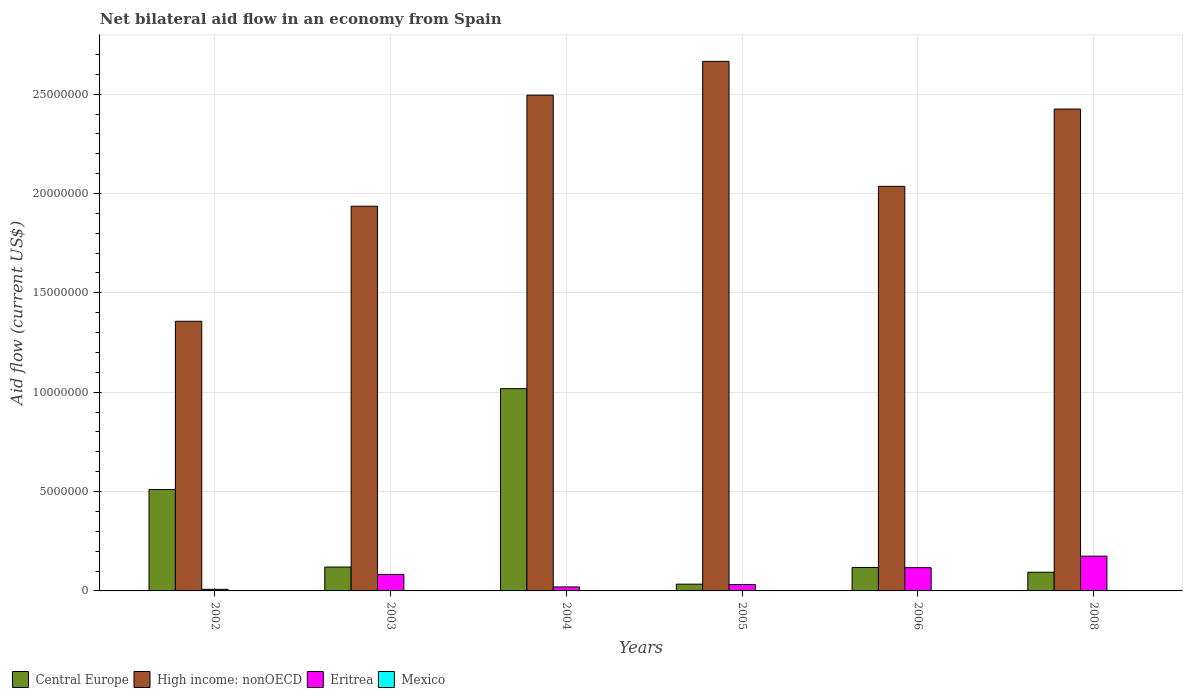How many groups of bars are there?
Your answer should be compact. 6. Are the number of bars per tick equal to the number of legend labels?
Your answer should be compact. No. What is the label of the 2nd group of bars from the left?
Your response must be concise. 2003. In how many cases, is the number of bars for a given year not equal to the number of legend labels?
Keep it short and to the point. 6. What is the net bilateral aid flow in Mexico in 2002?
Your answer should be very brief. 0. Across all years, what is the maximum net bilateral aid flow in Central Europe?
Keep it short and to the point. 1.02e+07. In which year was the net bilateral aid flow in Central Europe maximum?
Ensure brevity in your answer.  2004. What is the total net bilateral aid flow in Eritrea in the graph?
Your response must be concise. 4.35e+06. What is the difference between the net bilateral aid flow in Central Europe in 2002 and that in 2003?
Your answer should be very brief. 3.90e+06. What is the difference between the net bilateral aid flow in High income: nonOECD in 2005 and the net bilateral aid flow in Eritrea in 2004?
Your answer should be very brief. 2.64e+07. What is the average net bilateral aid flow in High income: nonOECD per year?
Keep it short and to the point. 2.15e+07. In the year 2004, what is the difference between the net bilateral aid flow in Central Europe and net bilateral aid flow in Eritrea?
Provide a succinct answer. 9.98e+06. In how many years, is the net bilateral aid flow in High income: nonOECD greater than 2000000 US$?
Give a very brief answer. 6. What is the ratio of the net bilateral aid flow in Central Europe in 2003 to that in 2005?
Ensure brevity in your answer.  3.53. What is the difference between the highest and the second highest net bilateral aid flow in High income: nonOECD?
Offer a very short reply. 1.70e+06. What is the difference between the highest and the lowest net bilateral aid flow in Central Europe?
Your answer should be very brief. 9.84e+06. Is the sum of the net bilateral aid flow in High income: nonOECD in 2002 and 2003 greater than the maximum net bilateral aid flow in Mexico across all years?
Your answer should be very brief. Yes. Is it the case that in every year, the sum of the net bilateral aid flow in Mexico and net bilateral aid flow in Central Europe is greater than the net bilateral aid flow in High income: nonOECD?
Keep it short and to the point. No. How many bars are there?
Offer a terse response. 18. How many years are there in the graph?
Your response must be concise. 6. What is the difference between two consecutive major ticks on the Y-axis?
Make the answer very short. 5.00e+06. Are the values on the major ticks of Y-axis written in scientific E-notation?
Your answer should be compact. No. Does the graph contain any zero values?
Make the answer very short. Yes. Does the graph contain grids?
Provide a short and direct response. Yes. Where does the legend appear in the graph?
Your answer should be compact. Bottom left. How many legend labels are there?
Your response must be concise. 4. What is the title of the graph?
Your answer should be very brief. Net bilateral aid flow in an economy from Spain. Does "Congo (Republic)" appear as one of the legend labels in the graph?
Keep it short and to the point. No. What is the Aid flow (current US$) in Central Europe in 2002?
Make the answer very short. 5.10e+06. What is the Aid flow (current US$) in High income: nonOECD in 2002?
Provide a succinct answer. 1.36e+07. What is the Aid flow (current US$) in Mexico in 2002?
Offer a very short reply. 0. What is the Aid flow (current US$) of Central Europe in 2003?
Provide a succinct answer. 1.20e+06. What is the Aid flow (current US$) in High income: nonOECD in 2003?
Offer a terse response. 1.94e+07. What is the Aid flow (current US$) in Eritrea in 2003?
Give a very brief answer. 8.30e+05. What is the Aid flow (current US$) in Mexico in 2003?
Provide a succinct answer. 0. What is the Aid flow (current US$) in Central Europe in 2004?
Ensure brevity in your answer.  1.02e+07. What is the Aid flow (current US$) of High income: nonOECD in 2004?
Your answer should be compact. 2.50e+07. What is the Aid flow (current US$) in Eritrea in 2004?
Offer a terse response. 2.00e+05. What is the Aid flow (current US$) in Mexico in 2004?
Provide a short and direct response. 0. What is the Aid flow (current US$) of High income: nonOECD in 2005?
Your answer should be compact. 2.66e+07. What is the Aid flow (current US$) of Mexico in 2005?
Your answer should be compact. 0. What is the Aid flow (current US$) of Central Europe in 2006?
Keep it short and to the point. 1.18e+06. What is the Aid flow (current US$) in High income: nonOECD in 2006?
Offer a very short reply. 2.04e+07. What is the Aid flow (current US$) in Eritrea in 2006?
Offer a terse response. 1.17e+06. What is the Aid flow (current US$) of Mexico in 2006?
Offer a terse response. 0. What is the Aid flow (current US$) in Central Europe in 2008?
Your response must be concise. 9.40e+05. What is the Aid flow (current US$) of High income: nonOECD in 2008?
Give a very brief answer. 2.42e+07. What is the Aid flow (current US$) in Eritrea in 2008?
Provide a short and direct response. 1.75e+06. What is the Aid flow (current US$) in Mexico in 2008?
Your answer should be very brief. 0. Across all years, what is the maximum Aid flow (current US$) in Central Europe?
Offer a very short reply. 1.02e+07. Across all years, what is the maximum Aid flow (current US$) in High income: nonOECD?
Offer a very short reply. 2.66e+07. Across all years, what is the maximum Aid flow (current US$) in Eritrea?
Provide a succinct answer. 1.75e+06. Across all years, what is the minimum Aid flow (current US$) of High income: nonOECD?
Provide a succinct answer. 1.36e+07. What is the total Aid flow (current US$) in Central Europe in the graph?
Offer a very short reply. 1.89e+07. What is the total Aid flow (current US$) in High income: nonOECD in the graph?
Offer a very short reply. 1.29e+08. What is the total Aid flow (current US$) in Eritrea in the graph?
Your response must be concise. 4.35e+06. What is the total Aid flow (current US$) of Mexico in the graph?
Your answer should be compact. 0. What is the difference between the Aid flow (current US$) in Central Europe in 2002 and that in 2003?
Offer a very short reply. 3.90e+06. What is the difference between the Aid flow (current US$) of High income: nonOECD in 2002 and that in 2003?
Provide a succinct answer. -5.79e+06. What is the difference between the Aid flow (current US$) of Eritrea in 2002 and that in 2003?
Your answer should be very brief. -7.50e+05. What is the difference between the Aid flow (current US$) in Central Europe in 2002 and that in 2004?
Provide a succinct answer. -5.08e+06. What is the difference between the Aid flow (current US$) in High income: nonOECD in 2002 and that in 2004?
Ensure brevity in your answer.  -1.14e+07. What is the difference between the Aid flow (current US$) of Eritrea in 2002 and that in 2004?
Your response must be concise. -1.20e+05. What is the difference between the Aid flow (current US$) of Central Europe in 2002 and that in 2005?
Offer a very short reply. 4.76e+06. What is the difference between the Aid flow (current US$) in High income: nonOECD in 2002 and that in 2005?
Ensure brevity in your answer.  -1.31e+07. What is the difference between the Aid flow (current US$) of Central Europe in 2002 and that in 2006?
Your answer should be very brief. 3.92e+06. What is the difference between the Aid flow (current US$) in High income: nonOECD in 2002 and that in 2006?
Keep it short and to the point. -6.79e+06. What is the difference between the Aid flow (current US$) of Eritrea in 2002 and that in 2006?
Give a very brief answer. -1.09e+06. What is the difference between the Aid flow (current US$) in Central Europe in 2002 and that in 2008?
Provide a succinct answer. 4.16e+06. What is the difference between the Aid flow (current US$) in High income: nonOECD in 2002 and that in 2008?
Your response must be concise. -1.07e+07. What is the difference between the Aid flow (current US$) in Eritrea in 2002 and that in 2008?
Your response must be concise. -1.67e+06. What is the difference between the Aid flow (current US$) of Central Europe in 2003 and that in 2004?
Make the answer very short. -8.98e+06. What is the difference between the Aid flow (current US$) of High income: nonOECD in 2003 and that in 2004?
Provide a short and direct response. -5.59e+06. What is the difference between the Aid flow (current US$) of Eritrea in 2003 and that in 2004?
Your response must be concise. 6.30e+05. What is the difference between the Aid flow (current US$) in Central Europe in 2003 and that in 2005?
Keep it short and to the point. 8.60e+05. What is the difference between the Aid flow (current US$) in High income: nonOECD in 2003 and that in 2005?
Keep it short and to the point. -7.29e+06. What is the difference between the Aid flow (current US$) of Eritrea in 2003 and that in 2005?
Your answer should be very brief. 5.10e+05. What is the difference between the Aid flow (current US$) of High income: nonOECD in 2003 and that in 2006?
Offer a very short reply. -1.00e+06. What is the difference between the Aid flow (current US$) in High income: nonOECD in 2003 and that in 2008?
Offer a terse response. -4.89e+06. What is the difference between the Aid flow (current US$) of Eritrea in 2003 and that in 2008?
Your answer should be compact. -9.20e+05. What is the difference between the Aid flow (current US$) of Central Europe in 2004 and that in 2005?
Your response must be concise. 9.84e+06. What is the difference between the Aid flow (current US$) of High income: nonOECD in 2004 and that in 2005?
Keep it short and to the point. -1.70e+06. What is the difference between the Aid flow (current US$) in Eritrea in 2004 and that in 2005?
Your answer should be compact. -1.20e+05. What is the difference between the Aid flow (current US$) in Central Europe in 2004 and that in 2006?
Your response must be concise. 9.00e+06. What is the difference between the Aid flow (current US$) in High income: nonOECD in 2004 and that in 2006?
Provide a short and direct response. 4.59e+06. What is the difference between the Aid flow (current US$) in Eritrea in 2004 and that in 2006?
Provide a succinct answer. -9.70e+05. What is the difference between the Aid flow (current US$) in Central Europe in 2004 and that in 2008?
Offer a very short reply. 9.24e+06. What is the difference between the Aid flow (current US$) of Eritrea in 2004 and that in 2008?
Your response must be concise. -1.55e+06. What is the difference between the Aid flow (current US$) in Central Europe in 2005 and that in 2006?
Keep it short and to the point. -8.40e+05. What is the difference between the Aid flow (current US$) in High income: nonOECD in 2005 and that in 2006?
Provide a short and direct response. 6.29e+06. What is the difference between the Aid flow (current US$) in Eritrea in 2005 and that in 2006?
Give a very brief answer. -8.50e+05. What is the difference between the Aid flow (current US$) of Central Europe in 2005 and that in 2008?
Your response must be concise. -6.00e+05. What is the difference between the Aid flow (current US$) in High income: nonOECD in 2005 and that in 2008?
Provide a succinct answer. 2.40e+06. What is the difference between the Aid flow (current US$) of Eritrea in 2005 and that in 2008?
Your answer should be very brief. -1.43e+06. What is the difference between the Aid flow (current US$) in Central Europe in 2006 and that in 2008?
Your answer should be very brief. 2.40e+05. What is the difference between the Aid flow (current US$) in High income: nonOECD in 2006 and that in 2008?
Make the answer very short. -3.89e+06. What is the difference between the Aid flow (current US$) in Eritrea in 2006 and that in 2008?
Provide a succinct answer. -5.80e+05. What is the difference between the Aid flow (current US$) in Central Europe in 2002 and the Aid flow (current US$) in High income: nonOECD in 2003?
Make the answer very short. -1.43e+07. What is the difference between the Aid flow (current US$) in Central Europe in 2002 and the Aid flow (current US$) in Eritrea in 2003?
Give a very brief answer. 4.27e+06. What is the difference between the Aid flow (current US$) of High income: nonOECD in 2002 and the Aid flow (current US$) of Eritrea in 2003?
Ensure brevity in your answer.  1.27e+07. What is the difference between the Aid flow (current US$) in Central Europe in 2002 and the Aid flow (current US$) in High income: nonOECD in 2004?
Your answer should be very brief. -1.98e+07. What is the difference between the Aid flow (current US$) in Central Europe in 2002 and the Aid flow (current US$) in Eritrea in 2004?
Offer a terse response. 4.90e+06. What is the difference between the Aid flow (current US$) of High income: nonOECD in 2002 and the Aid flow (current US$) of Eritrea in 2004?
Make the answer very short. 1.34e+07. What is the difference between the Aid flow (current US$) in Central Europe in 2002 and the Aid flow (current US$) in High income: nonOECD in 2005?
Ensure brevity in your answer.  -2.16e+07. What is the difference between the Aid flow (current US$) of Central Europe in 2002 and the Aid flow (current US$) of Eritrea in 2005?
Provide a succinct answer. 4.78e+06. What is the difference between the Aid flow (current US$) in High income: nonOECD in 2002 and the Aid flow (current US$) in Eritrea in 2005?
Your answer should be compact. 1.32e+07. What is the difference between the Aid flow (current US$) of Central Europe in 2002 and the Aid flow (current US$) of High income: nonOECD in 2006?
Keep it short and to the point. -1.53e+07. What is the difference between the Aid flow (current US$) in Central Europe in 2002 and the Aid flow (current US$) in Eritrea in 2006?
Your answer should be very brief. 3.93e+06. What is the difference between the Aid flow (current US$) in High income: nonOECD in 2002 and the Aid flow (current US$) in Eritrea in 2006?
Your response must be concise. 1.24e+07. What is the difference between the Aid flow (current US$) in Central Europe in 2002 and the Aid flow (current US$) in High income: nonOECD in 2008?
Offer a terse response. -1.92e+07. What is the difference between the Aid flow (current US$) of Central Europe in 2002 and the Aid flow (current US$) of Eritrea in 2008?
Ensure brevity in your answer.  3.35e+06. What is the difference between the Aid flow (current US$) of High income: nonOECD in 2002 and the Aid flow (current US$) of Eritrea in 2008?
Your answer should be very brief. 1.18e+07. What is the difference between the Aid flow (current US$) in Central Europe in 2003 and the Aid flow (current US$) in High income: nonOECD in 2004?
Offer a very short reply. -2.38e+07. What is the difference between the Aid flow (current US$) of Central Europe in 2003 and the Aid flow (current US$) of Eritrea in 2004?
Keep it short and to the point. 1.00e+06. What is the difference between the Aid flow (current US$) of High income: nonOECD in 2003 and the Aid flow (current US$) of Eritrea in 2004?
Keep it short and to the point. 1.92e+07. What is the difference between the Aid flow (current US$) of Central Europe in 2003 and the Aid flow (current US$) of High income: nonOECD in 2005?
Offer a very short reply. -2.54e+07. What is the difference between the Aid flow (current US$) in Central Europe in 2003 and the Aid flow (current US$) in Eritrea in 2005?
Your answer should be compact. 8.80e+05. What is the difference between the Aid flow (current US$) of High income: nonOECD in 2003 and the Aid flow (current US$) of Eritrea in 2005?
Make the answer very short. 1.90e+07. What is the difference between the Aid flow (current US$) of Central Europe in 2003 and the Aid flow (current US$) of High income: nonOECD in 2006?
Provide a short and direct response. -1.92e+07. What is the difference between the Aid flow (current US$) of High income: nonOECD in 2003 and the Aid flow (current US$) of Eritrea in 2006?
Make the answer very short. 1.82e+07. What is the difference between the Aid flow (current US$) in Central Europe in 2003 and the Aid flow (current US$) in High income: nonOECD in 2008?
Give a very brief answer. -2.30e+07. What is the difference between the Aid flow (current US$) of Central Europe in 2003 and the Aid flow (current US$) of Eritrea in 2008?
Your answer should be compact. -5.50e+05. What is the difference between the Aid flow (current US$) in High income: nonOECD in 2003 and the Aid flow (current US$) in Eritrea in 2008?
Provide a succinct answer. 1.76e+07. What is the difference between the Aid flow (current US$) in Central Europe in 2004 and the Aid flow (current US$) in High income: nonOECD in 2005?
Your answer should be very brief. -1.65e+07. What is the difference between the Aid flow (current US$) of Central Europe in 2004 and the Aid flow (current US$) of Eritrea in 2005?
Provide a short and direct response. 9.86e+06. What is the difference between the Aid flow (current US$) in High income: nonOECD in 2004 and the Aid flow (current US$) in Eritrea in 2005?
Your response must be concise. 2.46e+07. What is the difference between the Aid flow (current US$) of Central Europe in 2004 and the Aid flow (current US$) of High income: nonOECD in 2006?
Your answer should be very brief. -1.02e+07. What is the difference between the Aid flow (current US$) of Central Europe in 2004 and the Aid flow (current US$) of Eritrea in 2006?
Keep it short and to the point. 9.01e+06. What is the difference between the Aid flow (current US$) of High income: nonOECD in 2004 and the Aid flow (current US$) of Eritrea in 2006?
Your answer should be very brief. 2.38e+07. What is the difference between the Aid flow (current US$) in Central Europe in 2004 and the Aid flow (current US$) in High income: nonOECD in 2008?
Make the answer very short. -1.41e+07. What is the difference between the Aid flow (current US$) of Central Europe in 2004 and the Aid flow (current US$) of Eritrea in 2008?
Provide a succinct answer. 8.43e+06. What is the difference between the Aid flow (current US$) of High income: nonOECD in 2004 and the Aid flow (current US$) of Eritrea in 2008?
Your answer should be compact. 2.32e+07. What is the difference between the Aid flow (current US$) of Central Europe in 2005 and the Aid flow (current US$) of High income: nonOECD in 2006?
Offer a terse response. -2.00e+07. What is the difference between the Aid flow (current US$) in Central Europe in 2005 and the Aid flow (current US$) in Eritrea in 2006?
Your response must be concise. -8.30e+05. What is the difference between the Aid flow (current US$) in High income: nonOECD in 2005 and the Aid flow (current US$) in Eritrea in 2006?
Keep it short and to the point. 2.55e+07. What is the difference between the Aid flow (current US$) in Central Europe in 2005 and the Aid flow (current US$) in High income: nonOECD in 2008?
Keep it short and to the point. -2.39e+07. What is the difference between the Aid flow (current US$) in Central Europe in 2005 and the Aid flow (current US$) in Eritrea in 2008?
Make the answer very short. -1.41e+06. What is the difference between the Aid flow (current US$) of High income: nonOECD in 2005 and the Aid flow (current US$) of Eritrea in 2008?
Make the answer very short. 2.49e+07. What is the difference between the Aid flow (current US$) in Central Europe in 2006 and the Aid flow (current US$) in High income: nonOECD in 2008?
Provide a short and direct response. -2.31e+07. What is the difference between the Aid flow (current US$) in Central Europe in 2006 and the Aid flow (current US$) in Eritrea in 2008?
Your response must be concise. -5.70e+05. What is the difference between the Aid flow (current US$) of High income: nonOECD in 2006 and the Aid flow (current US$) of Eritrea in 2008?
Your response must be concise. 1.86e+07. What is the average Aid flow (current US$) in Central Europe per year?
Give a very brief answer. 3.16e+06. What is the average Aid flow (current US$) in High income: nonOECD per year?
Provide a short and direct response. 2.15e+07. What is the average Aid flow (current US$) in Eritrea per year?
Provide a short and direct response. 7.25e+05. In the year 2002, what is the difference between the Aid flow (current US$) in Central Europe and Aid flow (current US$) in High income: nonOECD?
Make the answer very short. -8.47e+06. In the year 2002, what is the difference between the Aid flow (current US$) of Central Europe and Aid flow (current US$) of Eritrea?
Your answer should be compact. 5.02e+06. In the year 2002, what is the difference between the Aid flow (current US$) of High income: nonOECD and Aid flow (current US$) of Eritrea?
Your response must be concise. 1.35e+07. In the year 2003, what is the difference between the Aid flow (current US$) of Central Europe and Aid flow (current US$) of High income: nonOECD?
Make the answer very short. -1.82e+07. In the year 2003, what is the difference between the Aid flow (current US$) of Central Europe and Aid flow (current US$) of Eritrea?
Ensure brevity in your answer.  3.70e+05. In the year 2003, what is the difference between the Aid flow (current US$) of High income: nonOECD and Aid flow (current US$) of Eritrea?
Give a very brief answer. 1.85e+07. In the year 2004, what is the difference between the Aid flow (current US$) in Central Europe and Aid flow (current US$) in High income: nonOECD?
Ensure brevity in your answer.  -1.48e+07. In the year 2004, what is the difference between the Aid flow (current US$) of Central Europe and Aid flow (current US$) of Eritrea?
Offer a terse response. 9.98e+06. In the year 2004, what is the difference between the Aid flow (current US$) in High income: nonOECD and Aid flow (current US$) in Eritrea?
Make the answer very short. 2.48e+07. In the year 2005, what is the difference between the Aid flow (current US$) in Central Europe and Aid flow (current US$) in High income: nonOECD?
Offer a terse response. -2.63e+07. In the year 2005, what is the difference between the Aid flow (current US$) of High income: nonOECD and Aid flow (current US$) of Eritrea?
Give a very brief answer. 2.63e+07. In the year 2006, what is the difference between the Aid flow (current US$) in Central Europe and Aid flow (current US$) in High income: nonOECD?
Your answer should be compact. -1.92e+07. In the year 2006, what is the difference between the Aid flow (current US$) in High income: nonOECD and Aid flow (current US$) in Eritrea?
Your answer should be compact. 1.92e+07. In the year 2008, what is the difference between the Aid flow (current US$) of Central Europe and Aid flow (current US$) of High income: nonOECD?
Your answer should be compact. -2.33e+07. In the year 2008, what is the difference between the Aid flow (current US$) of Central Europe and Aid flow (current US$) of Eritrea?
Your answer should be compact. -8.10e+05. In the year 2008, what is the difference between the Aid flow (current US$) in High income: nonOECD and Aid flow (current US$) in Eritrea?
Your response must be concise. 2.25e+07. What is the ratio of the Aid flow (current US$) in Central Europe in 2002 to that in 2003?
Your answer should be compact. 4.25. What is the ratio of the Aid flow (current US$) of High income: nonOECD in 2002 to that in 2003?
Give a very brief answer. 0.7. What is the ratio of the Aid flow (current US$) of Eritrea in 2002 to that in 2003?
Provide a short and direct response. 0.1. What is the ratio of the Aid flow (current US$) in Central Europe in 2002 to that in 2004?
Give a very brief answer. 0.5. What is the ratio of the Aid flow (current US$) in High income: nonOECD in 2002 to that in 2004?
Make the answer very short. 0.54. What is the ratio of the Aid flow (current US$) of Central Europe in 2002 to that in 2005?
Provide a short and direct response. 15. What is the ratio of the Aid flow (current US$) of High income: nonOECD in 2002 to that in 2005?
Your response must be concise. 0.51. What is the ratio of the Aid flow (current US$) in Central Europe in 2002 to that in 2006?
Keep it short and to the point. 4.32. What is the ratio of the Aid flow (current US$) in High income: nonOECD in 2002 to that in 2006?
Provide a short and direct response. 0.67. What is the ratio of the Aid flow (current US$) of Eritrea in 2002 to that in 2006?
Offer a terse response. 0.07. What is the ratio of the Aid flow (current US$) of Central Europe in 2002 to that in 2008?
Provide a short and direct response. 5.43. What is the ratio of the Aid flow (current US$) of High income: nonOECD in 2002 to that in 2008?
Make the answer very short. 0.56. What is the ratio of the Aid flow (current US$) of Eritrea in 2002 to that in 2008?
Make the answer very short. 0.05. What is the ratio of the Aid flow (current US$) of Central Europe in 2003 to that in 2004?
Give a very brief answer. 0.12. What is the ratio of the Aid flow (current US$) in High income: nonOECD in 2003 to that in 2004?
Your answer should be compact. 0.78. What is the ratio of the Aid flow (current US$) in Eritrea in 2003 to that in 2004?
Your answer should be very brief. 4.15. What is the ratio of the Aid flow (current US$) of Central Europe in 2003 to that in 2005?
Your answer should be compact. 3.53. What is the ratio of the Aid flow (current US$) of High income: nonOECD in 2003 to that in 2005?
Make the answer very short. 0.73. What is the ratio of the Aid flow (current US$) in Eritrea in 2003 to that in 2005?
Keep it short and to the point. 2.59. What is the ratio of the Aid flow (current US$) in Central Europe in 2003 to that in 2006?
Your answer should be very brief. 1.02. What is the ratio of the Aid flow (current US$) of High income: nonOECD in 2003 to that in 2006?
Your response must be concise. 0.95. What is the ratio of the Aid flow (current US$) in Eritrea in 2003 to that in 2006?
Provide a succinct answer. 0.71. What is the ratio of the Aid flow (current US$) in Central Europe in 2003 to that in 2008?
Give a very brief answer. 1.28. What is the ratio of the Aid flow (current US$) in High income: nonOECD in 2003 to that in 2008?
Keep it short and to the point. 0.8. What is the ratio of the Aid flow (current US$) in Eritrea in 2003 to that in 2008?
Keep it short and to the point. 0.47. What is the ratio of the Aid flow (current US$) of Central Europe in 2004 to that in 2005?
Offer a very short reply. 29.94. What is the ratio of the Aid flow (current US$) of High income: nonOECD in 2004 to that in 2005?
Provide a short and direct response. 0.94. What is the ratio of the Aid flow (current US$) in Eritrea in 2004 to that in 2005?
Provide a succinct answer. 0.62. What is the ratio of the Aid flow (current US$) of Central Europe in 2004 to that in 2006?
Give a very brief answer. 8.63. What is the ratio of the Aid flow (current US$) of High income: nonOECD in 2004 to that in 2006?
Your answer should be compact. 1.23. What is the ratio of the Aid flow (current US$) in Eritrea in 2004 to that in 2006?
Provide a succinct answer. 0.17. What is the ratio of the Aid flow (current US$) of Central Europe in 2004 to that in 2008?
Offer a very short reply. 10.83. What is the ratio of the Aid flow (current US$) in High income: nonOECD in 2004 to that in 2008?
Offer a terse response. 1.03. What is the ratio of the Aid flow (current US$) of Eritrea in 2004 to that in 2008?
Keep it short and to the point. 0.11. What is the ratio of the Aid flow (current US$) in Central Europe in 2005 to that in 2006?
Your answer should be compact. 0.29. What is the ratio of the Aid flow (current US$) in High income: nonOECD in 2005 to that in 2006?
Your response must be concise. 1.31. What is the ratio of the Aid flow (current US$) in Eritrea in 2005 to that in 2006?
Your response must be concise. 0.27. What is the ratio of the Aid flow (current US$) of Central Europe in 2005 to that in 2008?
Your response must be concise. 0.36. What is the ratio of the Aid flow (current US$) in High income: nonOECD in 2005 to that in 2008?
Make the answer very short. 1.1. What is the ratio of the Aid flow (current US$) in Eritrea in 2005 to that in 2008?
Ensure brevity in your answer.  0.18. What is the ratio of the Aid flow (current US$) of Central Europe in 2006 to that in 2008?
Offer a very short reply. 1.26. What is the ratio of the Aid flow (current US$) in High income: nonOECD in 2006 to that in 2008?
Keep it short and to the point. 0.84. What is the ratio of the Aid flow (current US$) of Eritrea in 2006 to that in 2008?
Provide a succinct answer. 0.67. What is the difference between the highest and the second highest Aid flow (current US$) of Central Europe?
Offer a terse response. 5.08e+06. What is the difference between the highest and the second highest Aid flow (current US$) of High income: nonOECD?
Provide a succinct answer. 1.70e+06. What is the difference between the highest and the second highest Aid flow (current US$) in Eritrea?
Your answer should be compact. 5.80e+05. What is the difference between the highest and the lowest Aid flow (current US$) of Central Europe?
Your answer should be compact. 9.84e+06. What is the difference between the highest and the lowest Aid flow (current US$) in High income: nonOECD?
Keep it short and to the point. 1.31e+07. What is the difference between the highest and the lowest Aid flow (current US$) of Eritrea?
Ensure brevity in your answer.  1.67e+06. 